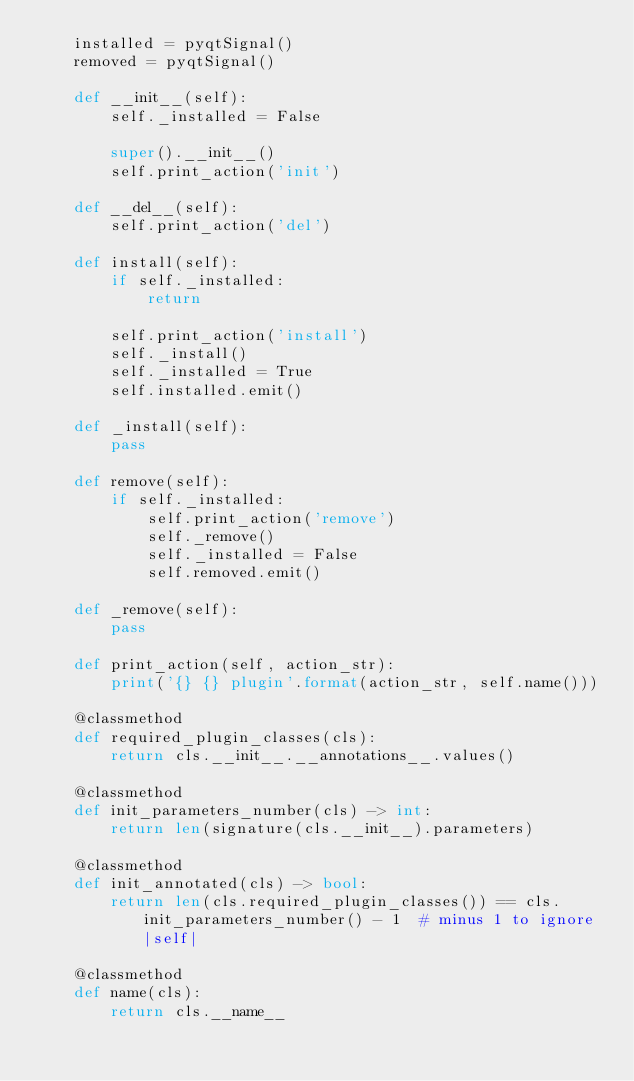<code> <loc_0><loc_0><loc_500><loc_500><_Python_>    installed = pyqtSignal()
    removed = pyqtSignal()

    def __init__(self):
        self._installed = False

        super().__init__()
        self.print_action('init')

    def __del__(self):
        self.print_action('del')

    def install(self):
        if self._installed:
            return

        self.print_action('install')
        self._install()
        self._installed = True
        self.installed.emit()

    def _install(self):
        pass

    def remove(self):
        if self._installed:
            self.print_action('remove')
            self._remove()
            self._installed = False
            self.removed.emit()

    def _remove(self):
        pass

    def print_action(self, action_str):
        print('{} {} plugin'.format(action_str, self.name()))

    @classmethod
    def required_plugin_classes(cls):
        return cls.__init__.__annotations__.values()

    @classmethod
    def init_parameters_number(cls) -> int:
        return len(signature(cls.__init__).parameters)

    @classmethod
    def init_annotated(cls) -> bool:
        return len(cls.required_plugin_classes()) == cls.init_parameters_number() - 1  # minus 1 to ignore |self|

    @classmethod
    def name(cls):
        return cls.__name__
</code> 